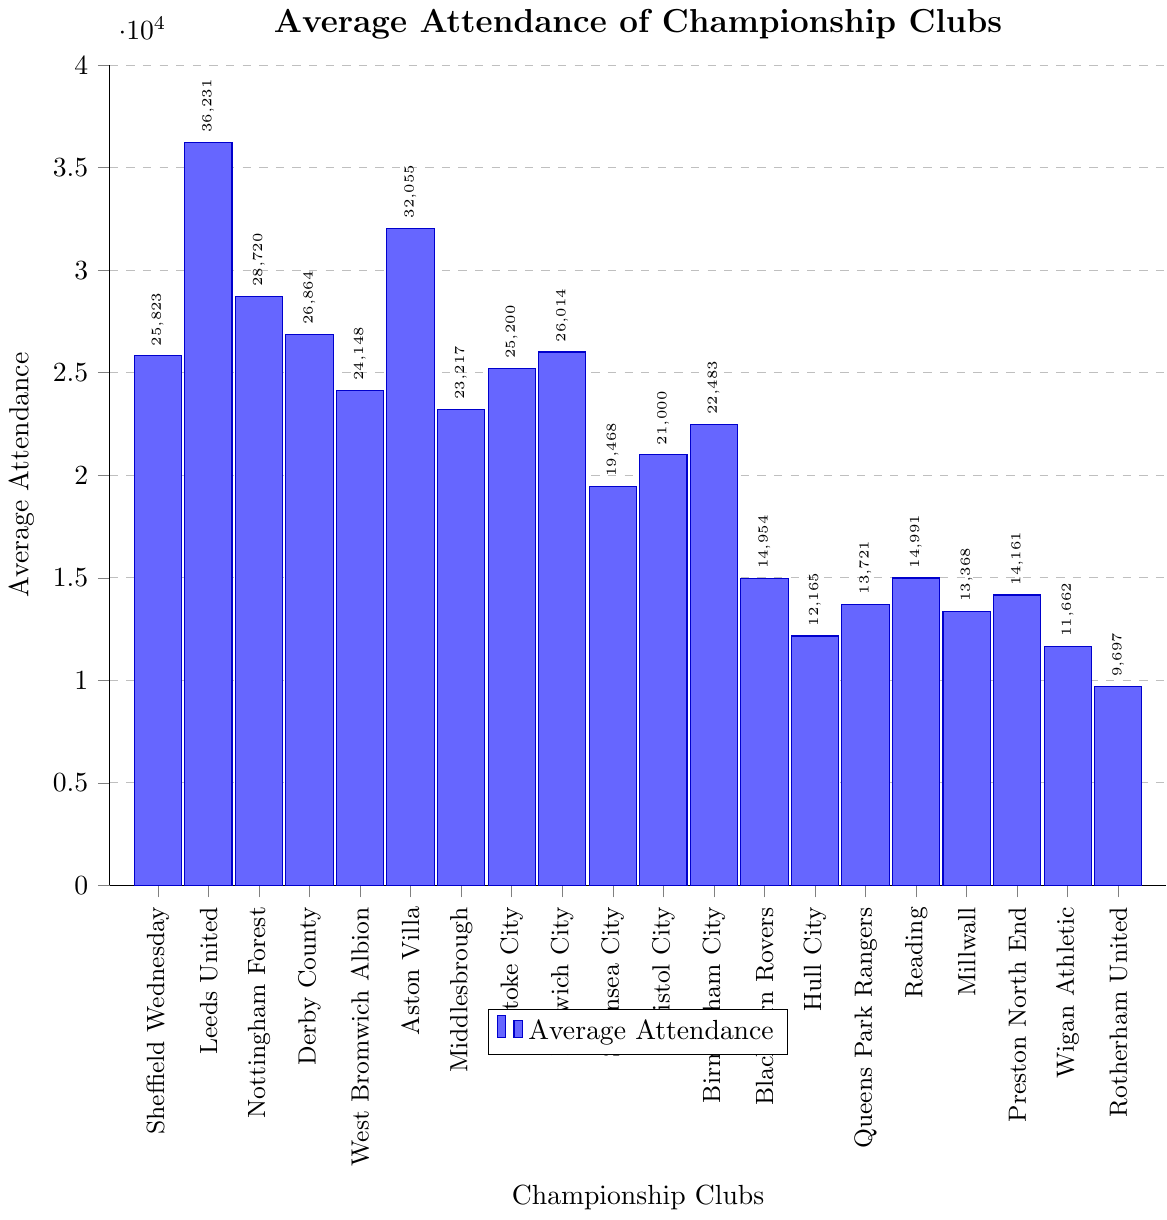What's the average attendance of Sheffield Wednesday's home matches? Look at the height of the bar representing Sheffield Wednesday on the x-axis and read the value near the coordinates, which is 25823.
Answer: 25823 How does Sheffield Wednesday's average attendance compare to Leeds United? Look at the height of the bars representing Sheffield Wednesday and Leeds United. Leeds United's bar is higher, indicating their average attendance is 36231, which is greater than Sheffield Wednesday's 25823.
Answer: Leeds United's average attendance is higher Which club has the highest average attendance? Observe the heights of all the bars. The bar for Leeds United is the tallest, with an average attendance of 36231.
Answer: Leeds United What is the difference in average attendance between Sheffield Wednesday and Aston Villa? Identify the average attendance for Sheffield Wednesday (25823) and Aston Villa (32055). Subtract Sheffield Wednesday's average from Aston Villa's: 32055 - 25823 = 6232.
Answer: 6232 What two clubs have an average attendance closest to each other? Compare the heights of the bars and identify the two bars that are nearest in height. West Bromwich Albion (24148) and Stoke City (25200) are closest.
Answer: West Bromwich Albion and Stoke City Where does Sheffield Wednesday rank among the Championship clubs in terms of average attendance? Compare the height of Sheffield Wednesday's bar with all others. Sheffield Wednesday's average attendance (25823) ranks 5th highest.
Answer: 5th What is the range of average attendance values shown? Identify the lowest and highest values. Rotherham United has the lowest (9697), and Leeds United has the highest (36231). The range is: 36231 - 9697 = 26534.
Answer: 26534 Which clubs have an average attendance lower than 15000? Identify the bars with values less than 15000: Blackburn Rovers (14954), Hull City (12165), Queens Park Rangers (13721), Reading (14991), Millwall (13368), Preston North End (14161), Wigan Athletic (11662), and Rotherham United (9697).
Answer: Blackburn Rovers, Hull City, Queens Park Rangers, Reading, Millwall, Preston North End, Wigan Athletic, Rotherham United How much higher is Aston Villa's average attendance compared to Norwich City? Find Norwich City's average attendance (26014) and Aston Villa's (32055). Calculate the difference: 32055 - 26014 = 6041.
Answer: 6041 